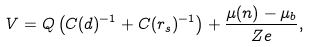<formula> <loc_0><loc_0><loc_500><loc_500>V = Q \left ( C ( d ) ^ { - 1 } + C ( r _ { s } ) ^ { - 1 } \right ) + \frac { \mu ( n ) - \mu _ { b } } { Z e } ,</formula> 